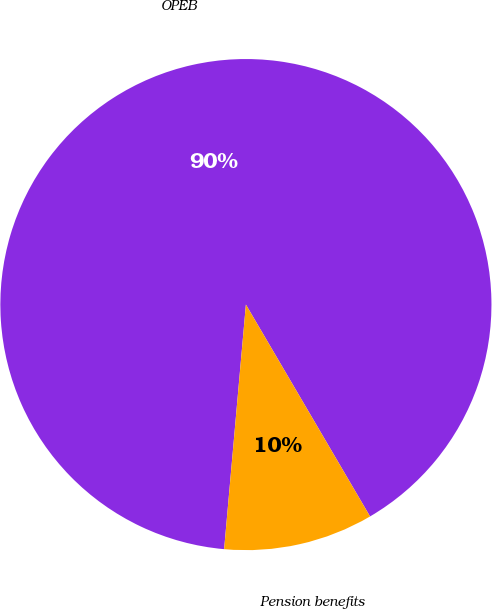<chart> <loc_0><loc_0><loc_500><loc_500><pie_chart><fcel>OPEB<fcel>Pension benefits<nl><fcel>90.15%<fcel>9.85%<nl></chart> 